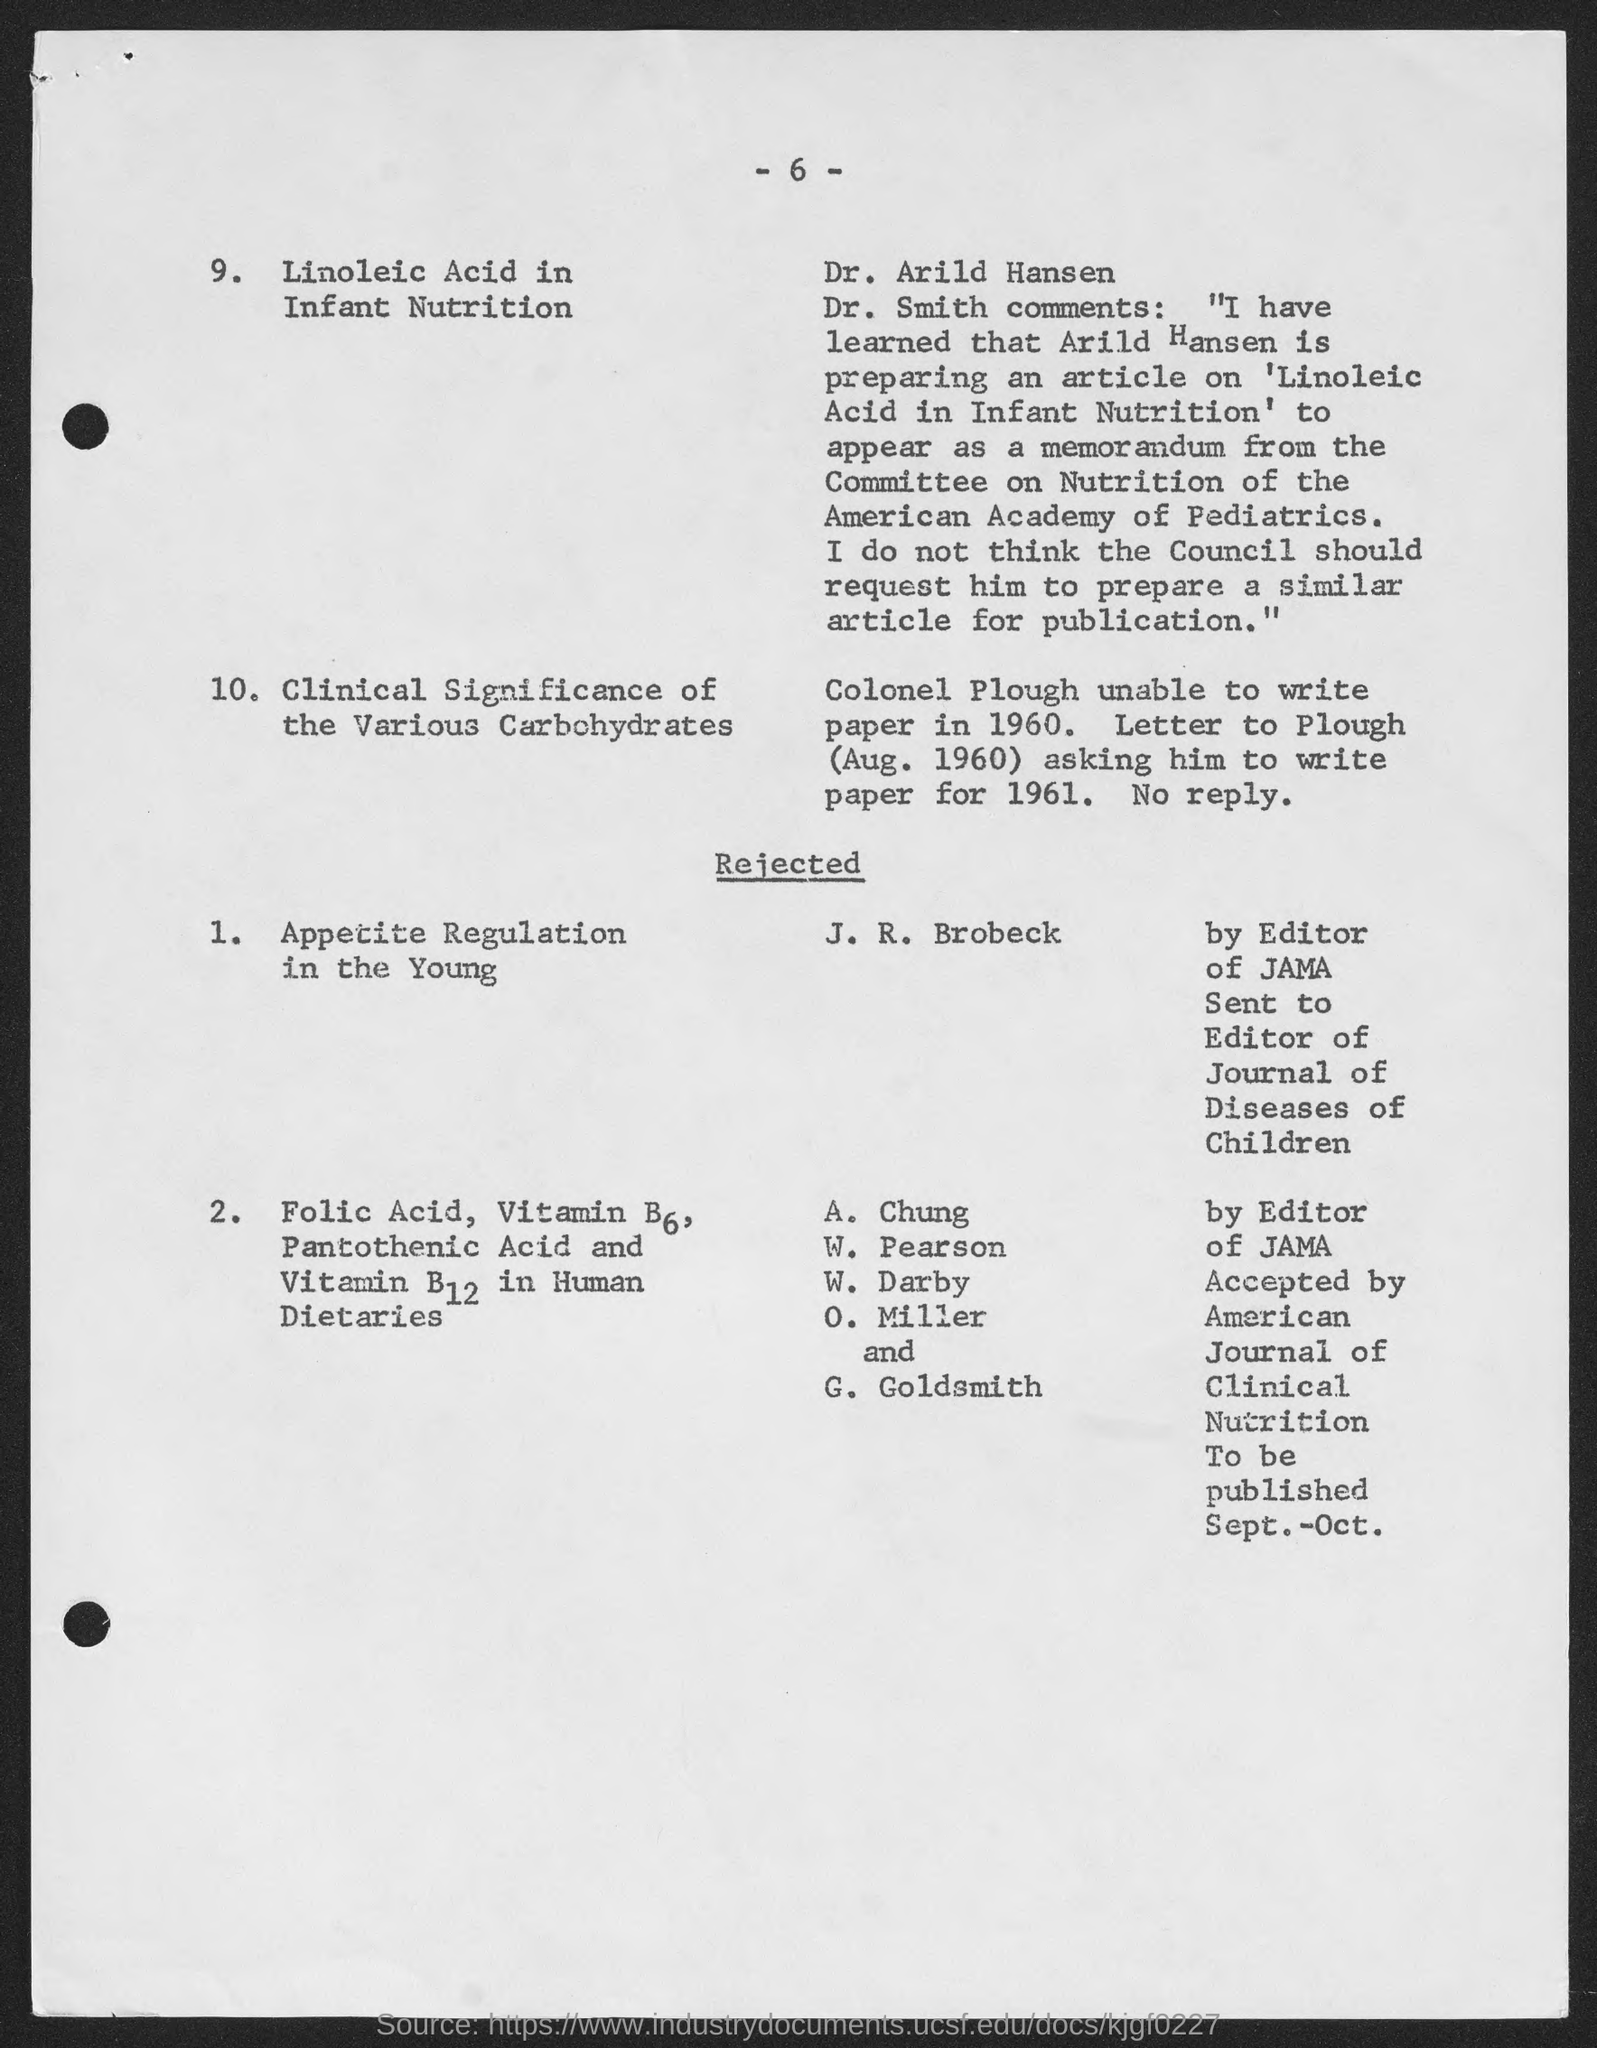What is the number at top of the page ?
Make the answer very short. - 6 -. 